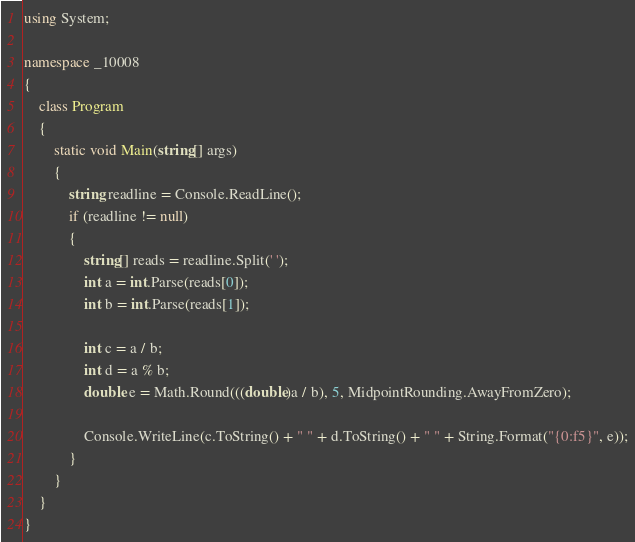Convert code to text. <code><loc_0><loc_0><loc_500><loc_500><_C#_>using System;

namespace _10008
{
    class Program
    {
        static void Main(string[] args)
        {
            string readline = Console.ReadLine();
            if (readline != null)
            {
                string[] reads = readline.Split(' ');
                int a = int.Parse(reads[0]);
                int b = int.Parse(reads[1]);

                int c = a / b;
                int d = a % b;
                double e = Math.Round(((double)a / b), 5, MidpointRounding.AwayFromZero);

                Console.WriteLine(c.ToString() + " " + d.ToString() + " " + String.Format("{0:f5}", e));
            }
        }
    }
}</code> 